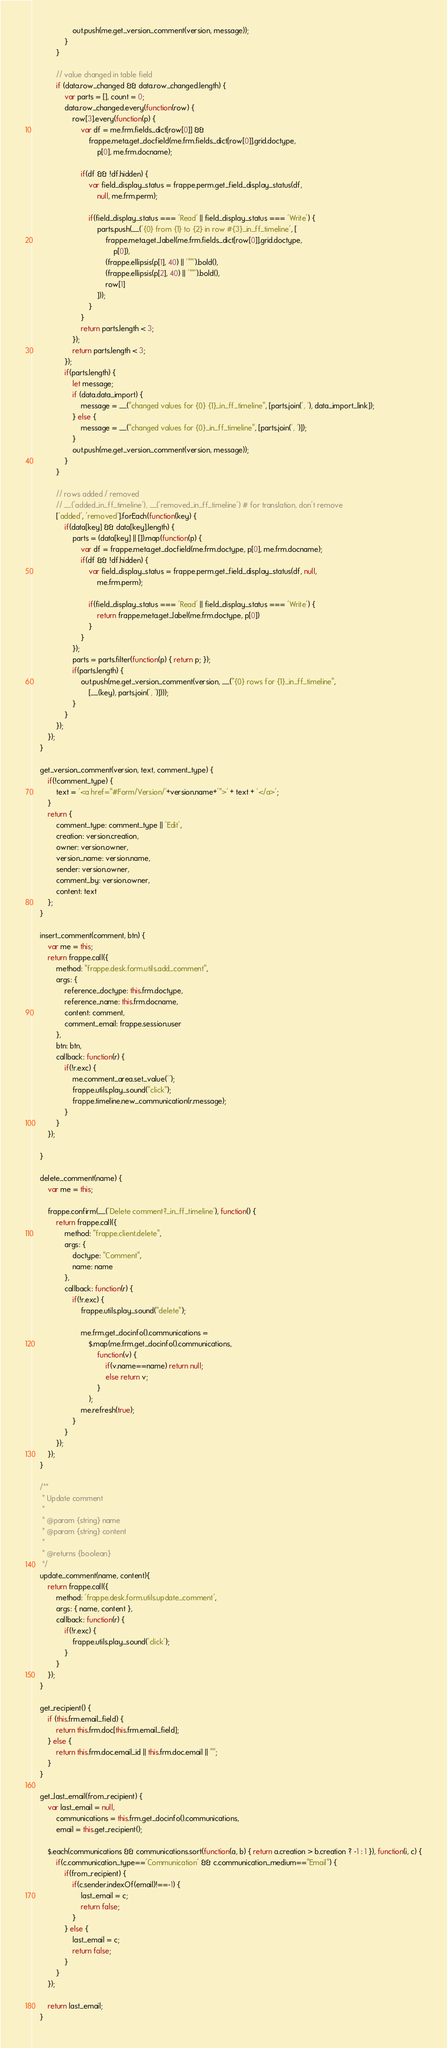Convert code to text. <code><loc_0><loc_0><loc_500><loc_500><_JavaScript_>					out.push(me.get_version_comment(version, message));
				}
			}

			// value changed in table field
			if (data.row_changed && data.row_changed.length) {
				var parts = [], count = 0;
				data.row_changed.every(function(row) {
					row[3].every(function(p) {
						var df = me.frm.fields_dict[row[0]] &&
							frappe.meta.get_docfield(me.frm.fields_dict[row[0]].grid.doctype,
								p[0], me.frm.docname);

						if(df && !df.hidden) {
							var field_display_status = frappe.perm.get_field_display_status(df,
								null, me.frm.perm);

							if(field_display_status === 'Read' || field_display_status === 'Write') {
								parts.push(__('{0} from {1} to {2} in row #{3}_in_ff_timeline', [
									frappe.meta.get_label(me.frm.fields_dict[row[0]].grid.doctype,
										p[0]),
									(frappe.ellipsis(p[1], 40) || '""').bold(),
									(frappe.ellipsis(p[2], 40) || '""').bold(),
									row[1]
								]));
							}
						}
						return parts.length < 3;
					});
					return parts.length < 3;
				});
				if(parts.length) {
					let message;
					if (data.data_import) {
						message = __("changed values for {0} {1}_in_ff_timeline", [parts.join(', '), data_import_link]);
					} else {
						message = __("changed values for {0}_in_ff_timeline", [parts.join(', ')]);
					}
					out.push(me.get_version_comment(version, message));
				}
			}

			// rows added / removed
			// __('added_in_ff_timeline'), __('removed_in_ff_timeline') # for translation, don't remove
			['added', 'removed'].forEach(function(key) {
				if(data[key] && data[key].length) {
					parts = (data[key] || []).map(function(p) {
						var df = frappe.meta.get_docfield(me.frm.doctype, p[0], me.frm.docname);
						if(df && !df.hidden) {
							var field_display_status = frappe.perm.get_field_display_status(df, null,
								me.frm.perm);

							if(field_display_status === 'Read' || field_display_status === 'Write') {
								return frappe.meta.get_label(me.frm.doctype, p[0])
							}
						}
					});
					parts = parts.filter(function(p) { return p; });
					if(parts.length) {
						out.push(me.get_version_comment(version, __("{0} rows for {1}_in_ff_timeline",
							[__(key), parts.join(', ')])));
					}
				}
			});
		});
	}

	get_version_comment(version, text, comment_type) {
		if(!comment_type) {
			text = '<a href="#Form/Version/'+version.name+'">' + text + '</a>';
		}
		return {
			comment_type: comment_type || 'Edit',
			creation: version.creation,
			owner: version.owner,
			version_name: version.name,
			sender: version.owner,
			comment_by: version.owner,
			content: text
		};
	}

	insert_comment(comment, btn) {
		var me = this;
		return frappe.call({
			method: "frappe.desk.form.utils.add_comment",
			args: {
				reference_doctype: this.frm.doctype,
				reference_name: this.frm.docname,
				content: comment,
				comment_email: frappe.session.user
			},
			btn: btn,
			callback: function(r) {
				if(!r.exc) {
					me.comment_area.set_value('');
					frappe.utils.play_sound("click");
					frappe.timeline.new_communication(r.message);
				}
			}
		});

	}

	delete_comment(name) {
		var me = this;

		frappe.confirm(__('Delete comment?_in_ff_timeline'), function() {
			return frappe.call({
				method: "frappe.client.delete",
				args: {
					doctype: "Comment",
					name: name
				},
				callback: function(r) {
					if(!r.exc) {
						frappe.utils.play_sound("delete");

						me.frm.get_docinfo().communications =
							$.map(me.frm.get_docinfo().communications,
								function(v) {
									if(v.name==name) return null;
									else return v;
								}
							);
						me.refresh(true);
					}
				}
			});
		});
	}

	/**
	 * Update comment
	 *
	 * @param {string} name
	 * @param {string} content
	 *
	 * @returns {boolean}
	 */
	update_comment(name, content){
		return frappe.call({
			method: 'frappe.desk.form.utils.update_comment',
			args: { name, content },
			callback: function(r) {
				if(!r.exc) {
					frappe.utils.play_sound('click');
				}
			}
		});
	}

	get_recipient() {
		if (this.frm.email_field) {
			return this.frm.doc[this.frm.email_field];
		} else {
			return this.frm.doc.email_id || this.frm.doc.email || "";
		}
	}

	get_last_email(from_recipient) {
		var last_email = null,
			communications = this.frm.get_docinfo().communications,
			email = this.get_recipient();

		$.each(communications && communications.sort(function(a, b) { return a.creation > b.creation ? -1 : 1 }), function(i, c) {
			if(c.communication_type=='Communication' && c.communication_medium=="Email") {
				if(from_recipient) {
					if(c.sender.indexOf(email)!==-1) {
						last_email = c;
						return false;
					}
				} else {
					last_email = c;
					return false;
				}
			}
		});

		return last_email;
	}
</code> 